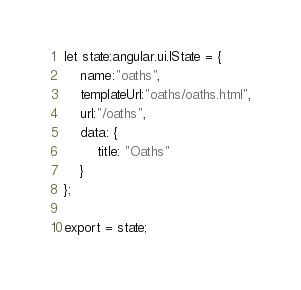<code> <loc_0><loc_0><loc_500><loc_500><_TypeScript_>let state:angular.ui.IState = {
    name:"oaths",
    templateUrl:"oaths/oaths.html",
    url:"/oaths",
    data: {
        title: "Oaths"
    }
};

export = state;</code> 